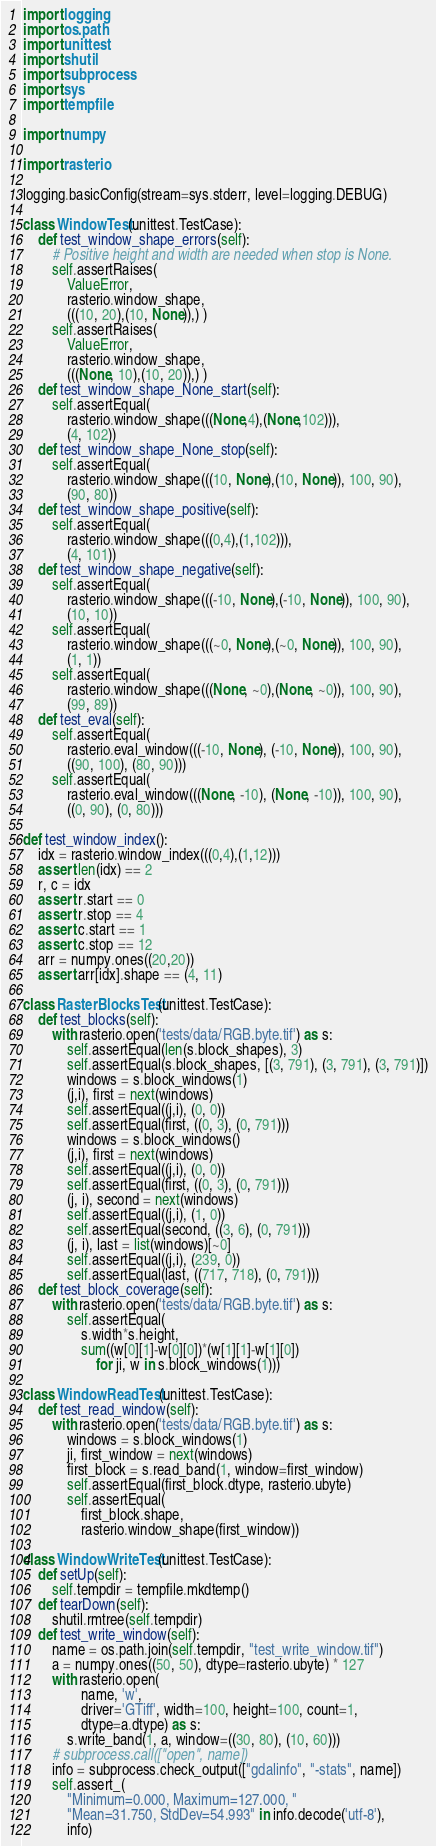Convert code to text. <code><loc_0><loc_0><loc_500><loc_500><_Python_>import logging
import os.path
import unittest
import shutil
import subprocess
import sys
import tempfile

import numpy

import rasterio

logging.basicConfig(stream=sys.stderr, level=logging.DEBUG)

class WindowTest(unittest.TestCase):
    def test_window_shape_errors(self):
        # Positive height and width are needed when stop is None.
        self.assertRaises(
            ValueError,
            rasterio.window_shape, 
            (((10, 20),(10, None)),) )
        self.assertRaises(
            ValueError,
            rasterio.window_shape, 
            (((None, 10),(10, 20)),) )
    def test_window_shape_None_start(self):
        self.assertEqual(
            rasterio.window_shape(((None,4),(None,102))),
            (4, 102))
    def test_window_shape_None_stop(self):
        self.assertEqual(
            rasterio.window_shape(((10, None),(10, None)), 100, 90),
            (90, 80))
    def test_window_shape_positive(self):
        self.assertEqual(
            rasterio.window_shape(((0,4),(1,102))),
            (4, 101))
    def test_window_shape_negative(self):
        self.assertEqual(
            rasterio.window_shape(((-10, None),(-10, None)), 100, 90),
            (10, 10))
        self.assertEqual(
            rasterio.window_shape(((~0, None),(~0, None)), 100, 90),
            (1, 1))
        self.assertEqual(
            rasterio.window_shape(((None, ~0),(None, ~0)), 100, 90),
            (99, 89))
    def test_eval(self):
        self.assertEqual(
            rasterio.eval_window(((-10, None), (-10, None)), 100, 90),
            ((90, 100), (80, 90)))
        self.assertEqual(
            rasterio.eval_window(((None, -10), (None, -10)), 100, 90),
            ((0, 90), (0, 80)))

def test_window_index():
    idx = rasterio.window_index(((0,4),(1,12)))
    assert len(idx) == 2
    r, c = idx
    assert r.start == 0
    assert r.stop == 4
    assert c.start == 1
    assert c.stop == 12
    arr = numpy.ones((20,20))
    assert arr[idx].shape == (4, 11)

class RasterBlocksTest(unittest.TestCase):
    def test_blocks(self):
        with rasterio.open('tests/data/RGB.byte.tif') as s:
            self.assertEqual(len(s.block_shapes), 3)
            self.assertEqual(s.block_shapes, [(3, 791), (3, 791), (3, 791)])
            windows = s.block_windows(1)
            (j,i), first = next(windows)
            self.assertEqual((j,i), (0, 0))
            self.assertEqual(first, ((0, 3), (0, 791)))
            windows = s.block_windows()
            (j,i), first = next(windows)
            self.assertEqual((j,i), (0, 0))
            self.assertEqual(first, ((0, 3), (0, 791)))
            (j, i), second = next(windows)
            self.assertEqual((j,i), (1, 0))
            self.assertEqual(second, ((3, 6), (0, 791)))
            (j, i), last = list(windows)[~0]
            self.assertEqual((j,i), (239, 0))
            self.assertEqual(last, ((717, 718), (0, 791)))
    def test_block_coverage(self):
        with rasterio.open('tests/data/RGB.byte.tif') as s:
            self.assertEqual(
                s.width*s.height,
                sum((w[0][1]-w[0][0])*(w[1][1]-w[1][0]) 
                    for ji, w in s.block_windows(1)))

class WindowReadTest(unittest.TestCase):
    def test_read_window(self):
        with rasterio.open('tests/data/RGB.byte.tif') as s:
            windows = s.block_windows(1)
            ji, first_window = next(windows)
            first_block = s.read_band(1, window=first_window)
            self.assertEqual(first_block.dtype, rasterio.ubyte)
            self.assertEqual(
                first_block.shape, 
                rasterio.window_shape(first_window))

class WindowWriteTest(unittest.TestCase):
    def setUp(self):
        self.tempdir = tempfile.mkdtemp()
    def tearDown(self):
        shutil.rmtree(self.tempdir)
    def test_write_window(self):
        name = os.path.join(self.tempdir, "test_write_window.tif")
        a = numpy.ones((50, 50), dtype=rasterio.ubyte) * 127
        with rasterio.open(
                name, 'w', 
                driver='GTiff', width=100, height=100, count=1, 
                dtype=a.dtype) as s:
            s.write_band(1, a, window=((30, 80), (10, 60)))
        # subprocess.call(["open", name])
        info = subprocess.check_output(["gdalinfo", "-stats", name])
        self.assert_(
            "Minimum=0.000, Maximum=127.000, "
            "Mean=31.750, StdDev=54.993" in info.decode('utf-8'),
            info)

</code> 